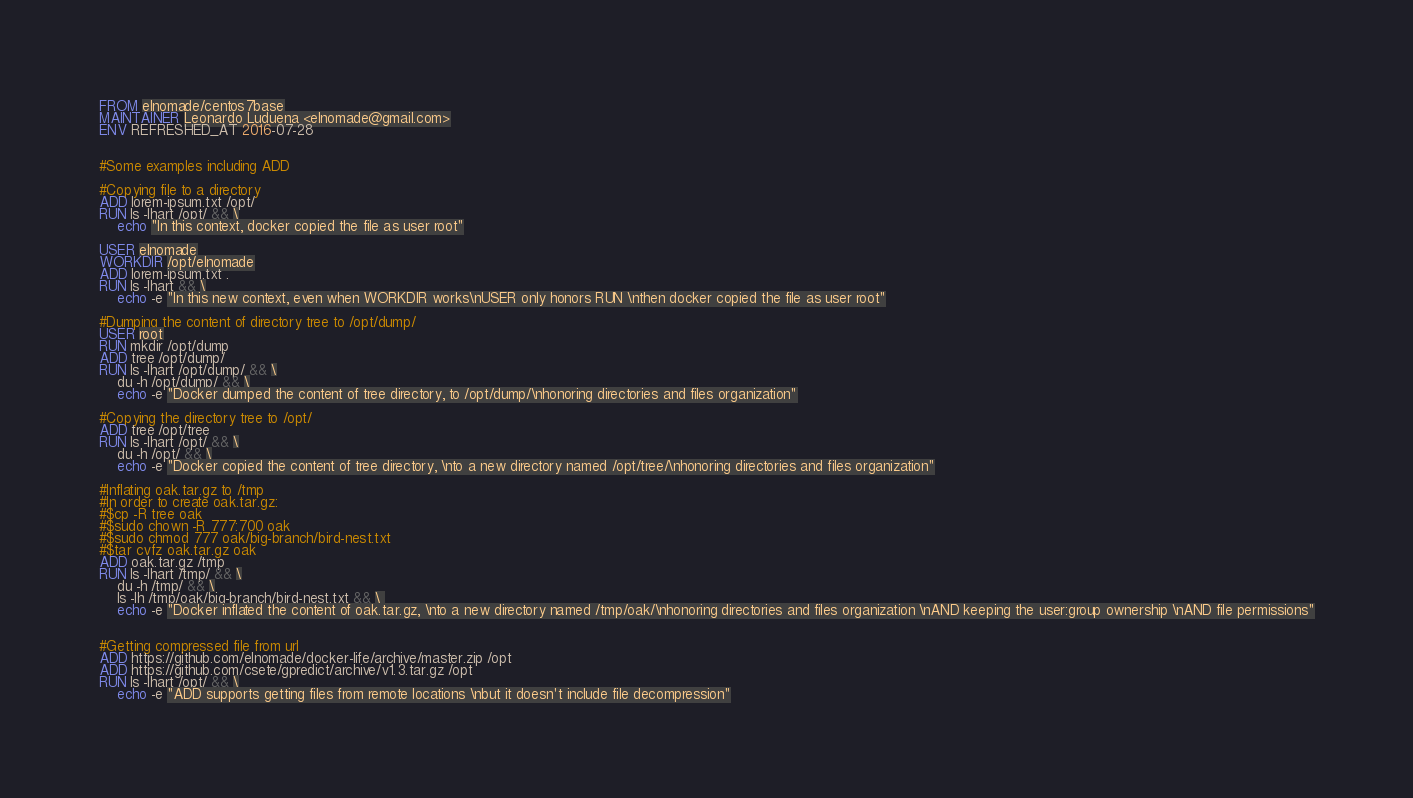Convert code to text. <code><loc_0><loc_0><loc_500><loc_500><_Dockerfile_>FROM elnomade/centos7base
MAINTAINER Leonardo Luduena <elnomade@gmail.com>
ENV REFRESHED_AT 2016-07-28


#Some examples including ADD

#Copying file to a directory
ADD lorem-ipsum.txt /opt/
RUN ls -lhart /opt/ && \
    echo "In this context, docker copied the file as user root"

USER elnomade
WORKDIR /opt/elnomade
ADD lorem-ipsum.txt .
RUN ls -lhart && \
    echo -e "In this new context, even when WORKDIR works\nUSER only honors RUN \nthen docker copied the file as user root"

#Dumping the content of directory tree to /opt/dump/
USER root
RUN mkdir /opt/dump
ADD tree /opt/dump/
RUN ls -lhart /opt/dump/ && \
    du -h /opt/dump/ && \
    echo -e "Docker dumped the content of tree directory, to /opt/dump/\nhonoring directories and files organization"

#Copying the directory tree to /opt/
ADD tree /opt/tree
RUN ls -lhart /opt/ && \
    du -h /opt/ && \
    echo -e "Docker copied the content of tree directory, \nto a new directory named /opt/tree/\nhonoring directories and files organization"

#Inflating oak.tar.gz to /tmp
#In order to create oak.tar.gz:
#$cp -R tree oak
#$sudo chown -R 777:700 oak
#$sudo chmod 777 oak/big-branch/bird-nest.txt
#$tar cvfz oak.tar.gz oak
ADD oak.tar.gz /tmp
RUN ls -lhart /tmp/ && \
    du -h /tmp/ && \
    ls -lh /tmp/oak/big-branch/bird-nest.txt && \    
    echo -e "Docker inflated the content of oak.tar.gz, \nto a new directory named /tmp/oak/\nhonoring directories and files organization \nAND keeping the user:group ownership \nAND file permissions"


#Getting compressed file from url
ADD https://github.com/elnomade/docker-life/archive/master.zip /opt
ADD https://github.com/csete/gpredict/archive/v1.3.tar.gz /opt
RUN ls -lhart /opt/ && \
	echo -e "ADD supports getting files from remote locations \nbut it doesn't include file decompression"
</code> 